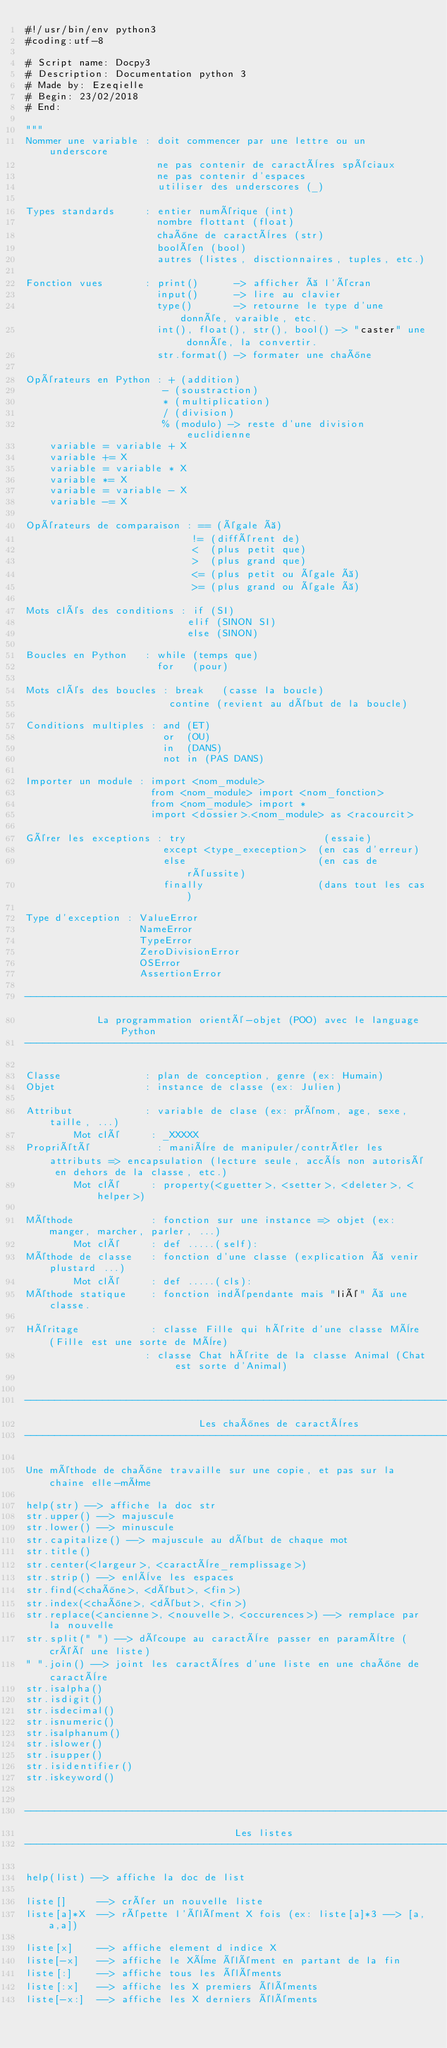Convert code to text. <code><loc_0><loc_0><loc_500><loc_500><_Python_>#!/usr/bin/env python3
#coding:utf-8

# Script name: Docpy3
# Description: Documentation python 3
# Made by: Ezeqielle
# Begin: 23/02/2018
# End: 

"""
Nommer une variable : doit commencer par une lettre ou un underscore
                      ne pas contenir de caractères spéciaux
                      ne pas contenir d'espaces
                      utiliser des underscores (_)

Types standards     : entier numérique (int)
                      nombre flottant (float)
                      chaîne de caractères (str)
                      booléen (bool)
                      autres (listes, disctionnaires, tuples, etc.)

Fonction vues       : print()      -> afficher à l'écran
                      input()      -> lire au clavier
                      type()       -> retourne le type d'une donnée, varaible, etc.
                      int(), float(), str(), bool() -> "caster" une donnée, la convertir.
                      str.format() -> formater une chaîne

Opérateurs en Python : + (addition)
                       - (soustraction)
                       * (multiplication)
                       / (division)
                       % (modulo) -> reste d'une division euclidienne
    variable = variable + X
    variable += X
    variable = variable * X
    variable *= X
    variable = variable - X
    variable -= X

Opérateurs de comparaison : == (égale à)
                            != (différent de)
                            <  (plus petit que)
                            >  (plus grand que)
                            <= (plus petit ou égale à)
                            >= (plus grand ou égale à)

Mots clés des conditions : if (SI)
                           elif (SINON SI)
                           else (SINON)

Boucles en Python   : while (temps que)
                      for   (pour)

Mots clés des boucles : break   (casse la boucle)
                        contine (revient au début de la boucle)

Conditions multiples : and (ET)
                       or  (OU)
                       in  (DANS)
                       not in (PAS DANS)

Importer un module : import <nom_module>
                     from <nom_module> import <nom_fonction>
                     from <nom_module> import *
                     import <dossier>.<nom_module> as <racourcit>

Gérer les exceptions : try                       (essaie)
                       except <type_exeception>  (en cas d'erreur)
                       else                      (en cas de réussite)
                       finally                   (dans tout les cas)

Type d'exception : ValueError
                   NameError
                   TypeError
                   ZeroDivisionError
                   OSError
                   AssertionError

------------------------------------------------------------------------------------
            La programmation orienté-objet (POO) avec le language Python
------------------------------------------------------------------------------------

Classe              : plan de conception, genre (ex: Humain)
Objet               : instance de classe (ex: Julien)

Attribut            : variable de clase (ex: prénom, age, sexe, taille, ...)
        Mot clé     : _XXXXX
Propriété           : manière de manipuler/contrôler les attributs => encapsulation (lecture seule, accès non autorisé en dehors de la classe, etc.)
        Mot clé     : property(<guetter>, <setter>, <deleter>, <helper>)

Méthode             : fonction sur une instance => objet (ex: manger, marcher, parler, ...)
        Mot clé     : def .....(self):
Méthode de classe   : fonction d'une classe (explication à venir plustard ...)
        Mot clé     : def .....(cls):
Méthode statique    : fonction indépendante mais "lié" à une classe.

Héritage            : classe Fille qui hérite d'une classe Mère (Fille est une sorte de Mère)
                    : classe Chat hérite de la classe Animal (Chat est sorte d'Animal)


------------------------------------------------------------------------------------
                             Les chaînes de caractères
------------------------------------------------------------------------------------

Une méthode de chaîne travaille sur une copie, et pas sur la chaine elle-même

help(str) --> affiche la doc str
str.upper() --> majuscule
str.lower() --> minuscule
str.capitalize() --> majuscule au début de chaque mot
str.title() 
str.center(<largeur>, <caractère_remplissage>)
str.strip() --> enlève les espaces 
str.find(<chaîne>, <début>, <fin>)
str.index(<chaîne>, <début>, <fin>)
str.replace(<ancienne>, <nouvelle>, <occurences>) --> remplace par la nouvelle
str.split(" ") --> découpe au caractère passer en paramètre (créé une liste)
" ".join() --> joint les caractères d'une liste en une chaîne de caractère 
str.isalpha()
str.isdigit()
str.isdecimal()
str.isnumeric()
str.isalphanum()
str.islower()
str.isupper()
str.isidentifier()
str.iskeyword()


------------------------------------------------------------------------------------
                                   Les listes
------------------------------------------------------------------------------------

help(list) --> affiche la doc de list

liste[]     --> créer un nouvelle liste
liste[a]*X  --> répette l'élément X fois (ex: liste[a]*3 --> [a,a,a])

liste[x]    --> affiche element d indice X
liste[-x]   --> affiche le Xème élément en partant de la fin
liste[:]    --> affiche tous les éléments
liste[:x]   --> affiche les X premiers éléments
liste[-x:]  --> affiche les X derniers éléments</code> 